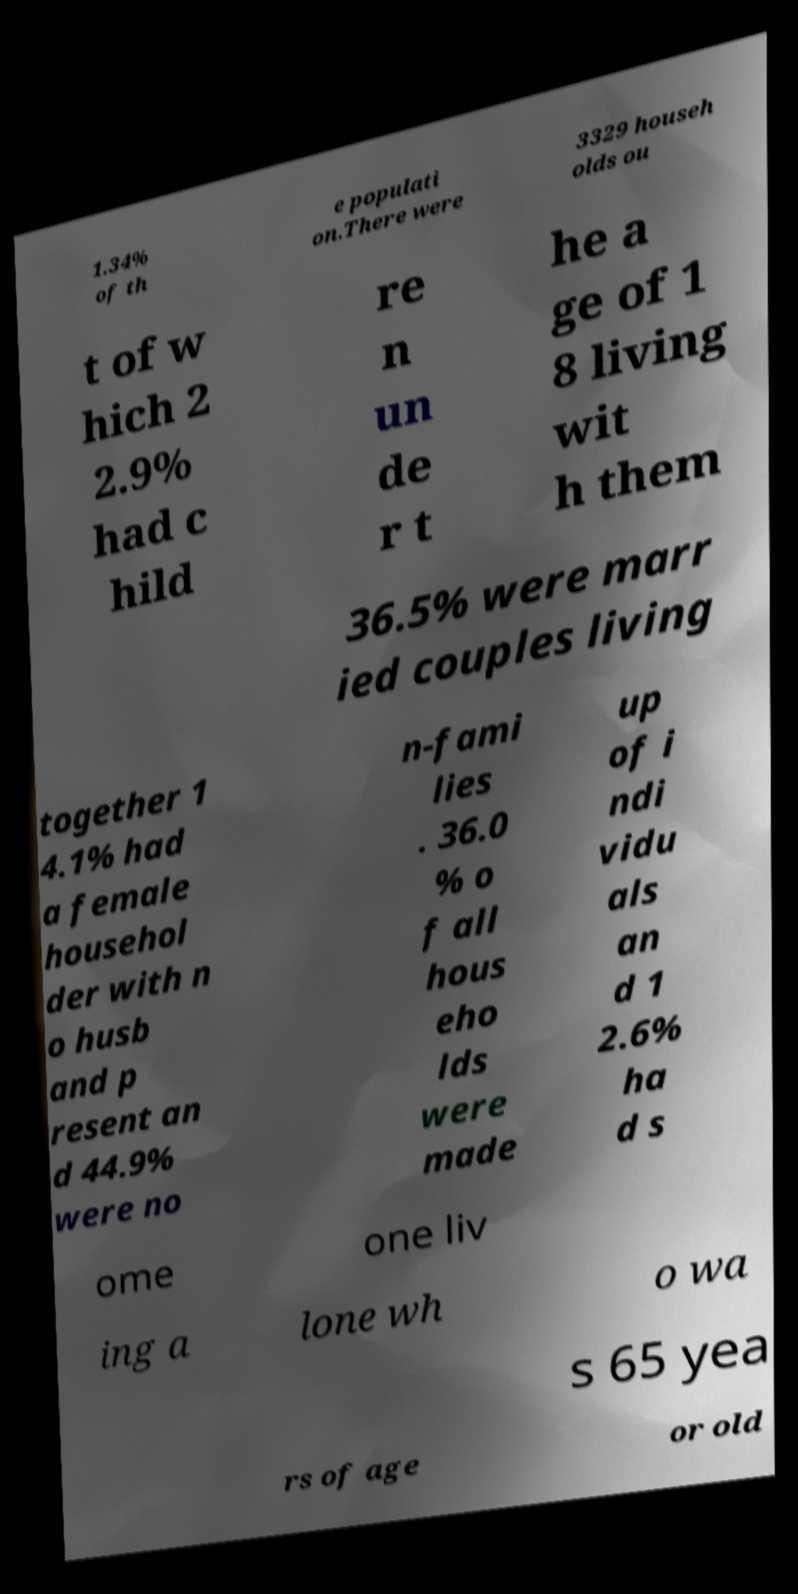Can you accurately transcribe the text from the provided image for me? 1.34% of th e populati on.There were 3329 househ olds ou t of w hich 2 2.9% had c hild re n un de r t he a ge of 1 8 living wit h them 36.5% were marr ied couples living together 1 4.1% had a female househol der with n o husb and p resent an d 44.9% were no n-fami lies . 36.0 % o f all hous eho lds were made up of i ndi vidu als an d 1 2.6% ha d s ome one liv ing a lone wh o wa s 65 yea rs of age or old 